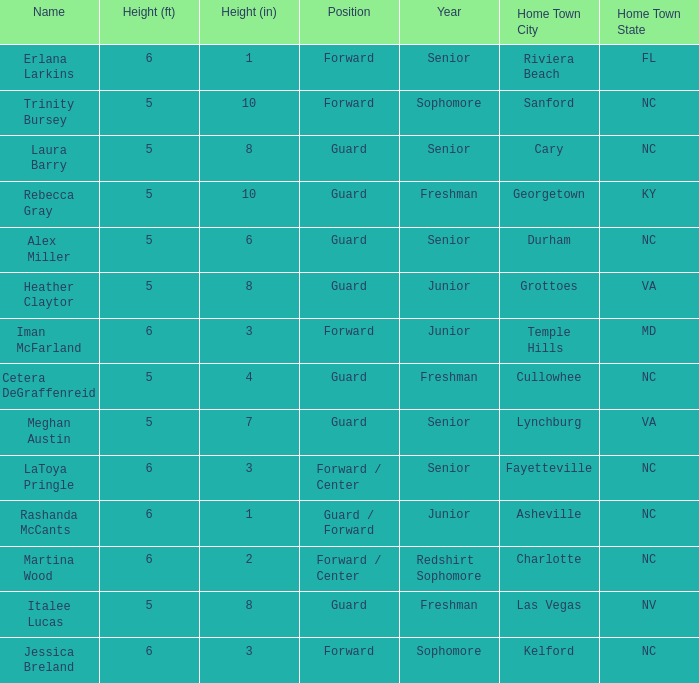How tall is the freshman guard Cetera Degraffenreid? 5-4. 